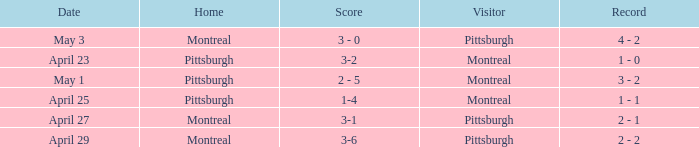What was the score on April 25? 1-4. 